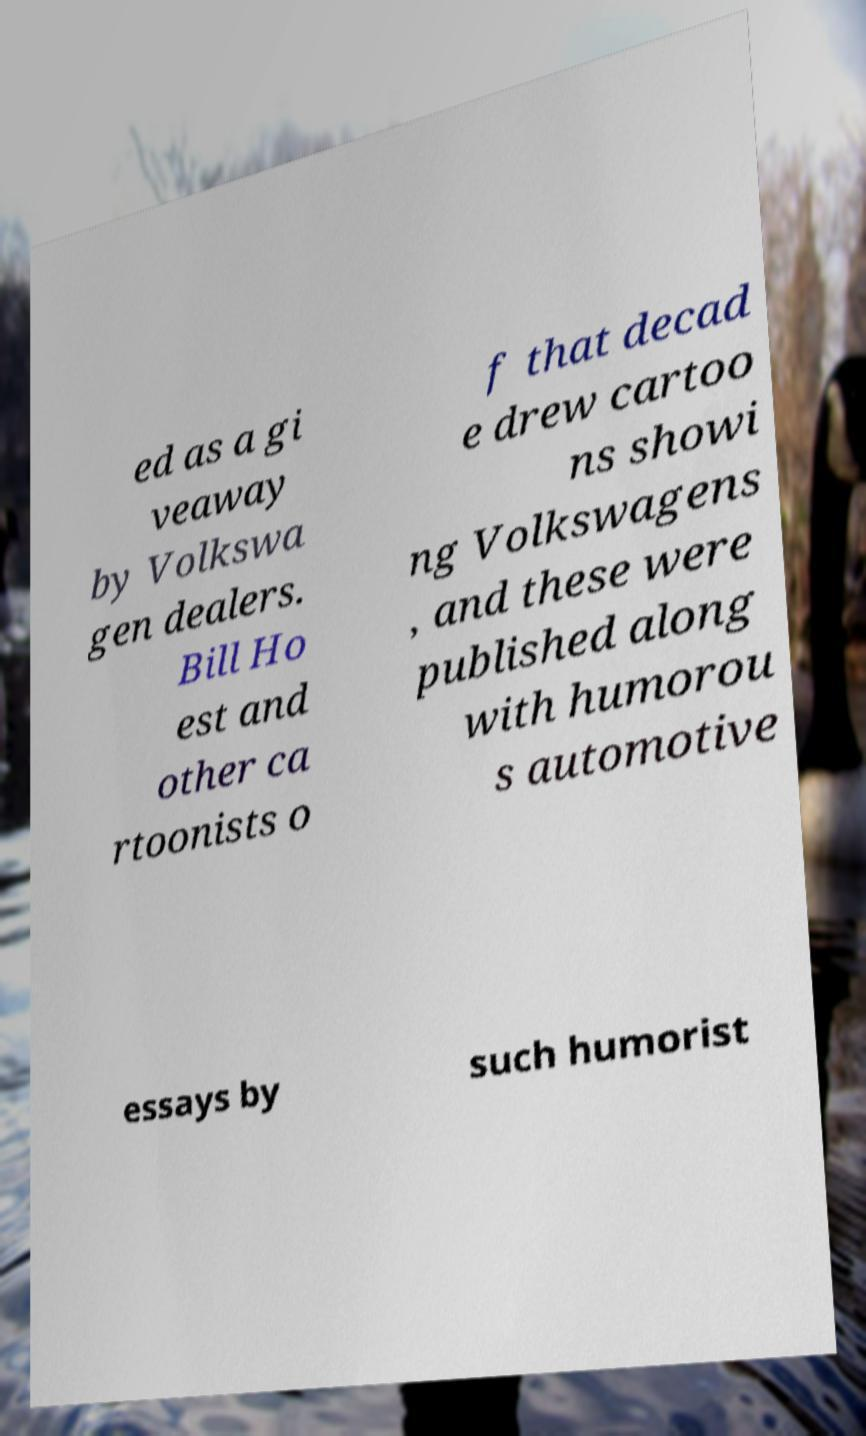For documentation purposes, I need the text within this image transcribed. Could you provide that? ed as a gi veaway by Volkswa gen dealers. Bill Ho est and other ca rtoonists o f that decad e drew cartoo ns showi ng Volkswagens , and these were published along with humorou s automotive essays by such humorist 